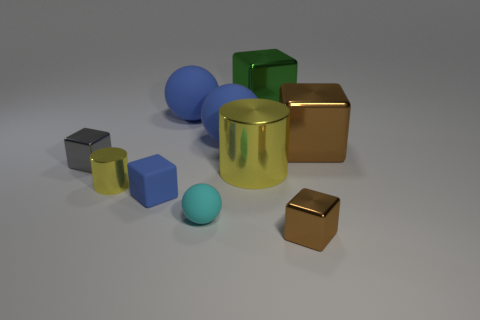What is the cube that is on the left side of the big metal cylinder and behind the tiny yellow cylinder made of?
Make the answer very short. Metal. Are there any yellow objects that have the same size as the cyan sphere?
Make the answer very short. Yes. What material is the yellow thing that is the same size as the blue block?
Offer a terse response. Metal. There is a small brown metallic block; how many brown blocks are behind it?
Your response must be concise. 1. Do the small metallic thing that is on the right side of the green shiny cube and the big yellow metal object have the same shape?
Your answer should be very brief. No. Is there another small green metallic object that has the same shape as the green thing?
Ensure brevity in your answer.  No. There is another cylinder that is the same color as the tiny cylinder; what material is it?
Offer a terse response. Metal. There is a small object behind the yellow thing that is to the right of the small metallic cylinder; what is its shape?
Keep it short and to the point. Cube. What number of tiny balls are made of the same material as the cyan thing?
Keep it short and to the point. 0. The other large block that is the same material as the large brown cube is what color?
Keep it short and to the point. Green. 